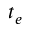Convert formula to latex. <formula><loc_0><loc_0><loc_500><loc_500>t _ { e }</formula> 